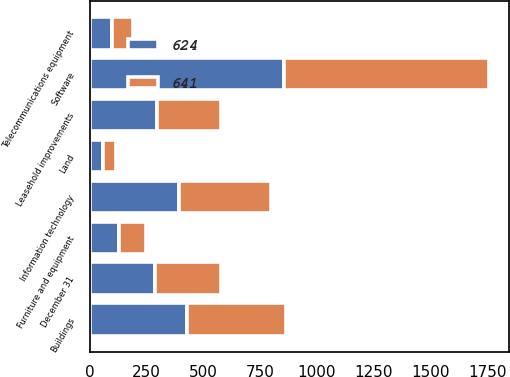<chart> <loc_0><loc_0><loc_500><loc_500><stacked_bar_chart><ecel><fcel>December 31<fcel>Software<fcel>Buildings<fcel>Information technology<fcel>Leasehold improvements<fcel>Furniture and equipment<fcel>Telecommunications equipment<fcel>Land<nl><fcel>641<fcel>289<fcel>902<fcel>438<fcel>405<fcel>282<fcel>118<fcel>91<fcel>57<nl><fcel>624<fcel>289<fcel>854<fcel>428<fcel>392<fcel>296<fcel>128<fcel>100<fcel>57<nl></chart> 